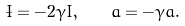<formula> <loc_0><loc_0><loc_500><loc_500>\dot { I } = - 2 \gamma I , \quad \dot { a } = - \gamma a .</formula> 